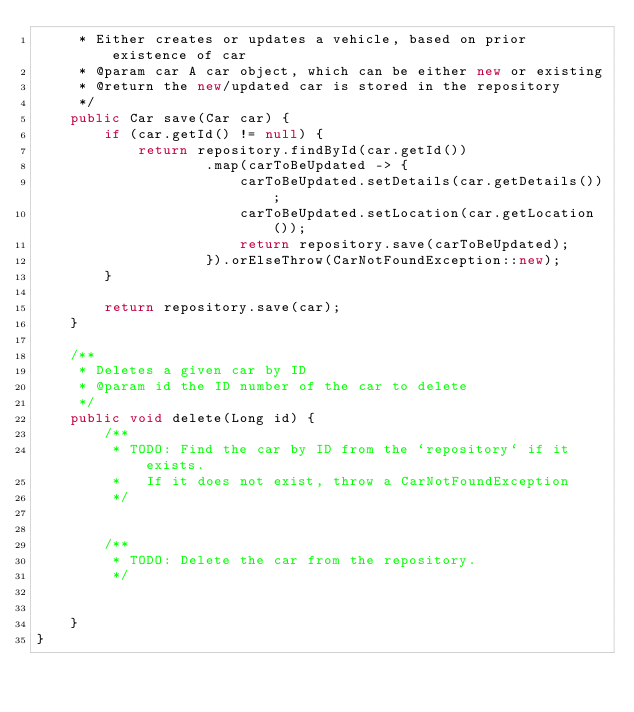Convert code to text. <code><loc_0><loc_0><loc_500><loc_500><_Java_>     * Either creates or updates a vehicle, based on prior existence of car
     * @param car A car object, which can be either new or existing
     * @return the new/updated car is stored in the repository
     */
    public Car save(Car car) {
        if (car.getId() != null) {
            return repository.findById(car.getId())
                    .map(carToBeUpdated -> {
                        carToBeUpdated.setDetails(car.getDetails());
                        carToBeUpdated.setLocation(car.getLocation());
                        return repository.save(carToBeUpdated);
                    }).orElseThrow(CarNotFoundException::new);
        }

        return repository.save(car);
    }

    /**
     * Deletes a given car by ID
     * @param id the ID number of the car to delete
     */
    public void delete(Long id) {
        /**
         * TODO: Find the car by ID from the `repository` if it exists.
         *   If it does not exist, throw a CarNotFoundException
         */


        /**
         * TODO: Delete the car from the repository.
         */


    }
}
</code> 